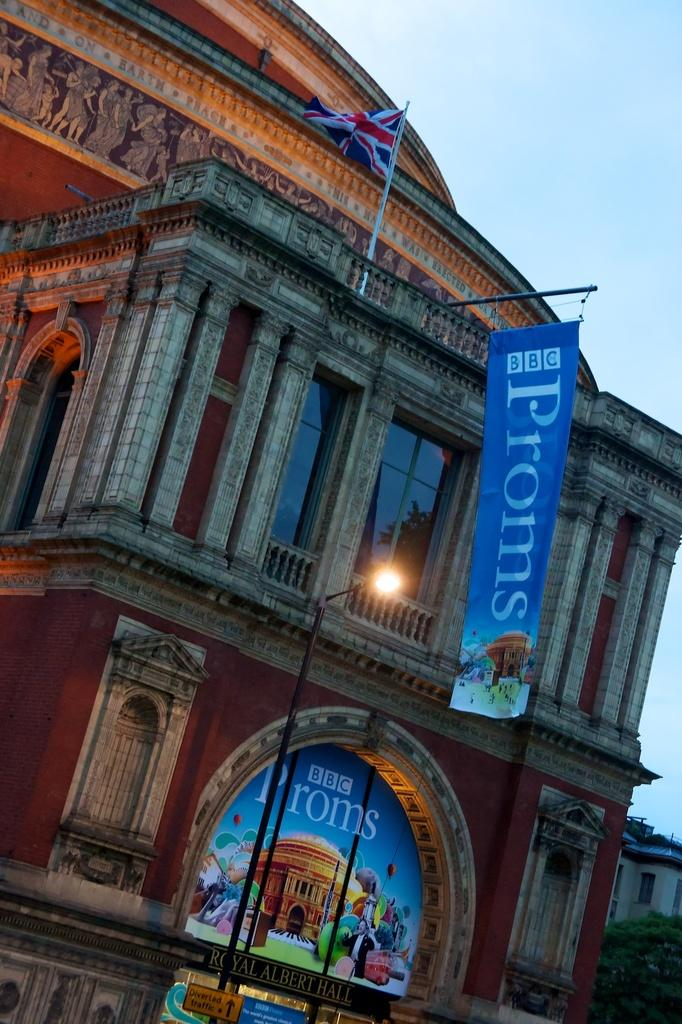What is the color of the building in the image? The building in the image is brown-colored. What other colorful element can be seen in the image? There is a blue-colored banner in the image. What structures are present to provide illumination in the image? Light poles are present in the image. What national or organizational symbol is visible in the image? There is a flag in the image. What is the color of the sky in the image? The sky is blue in the image. Can you see any wires attached to the flag in the image? There is no mention of wires in the image, so we cannot determine if any are attached to the flag. What type of print can be seen on the banner in the image? The image does not provide information about any print or design on the banner. Is there a goat present in the image? No, there is no mention of a goat in the image. 